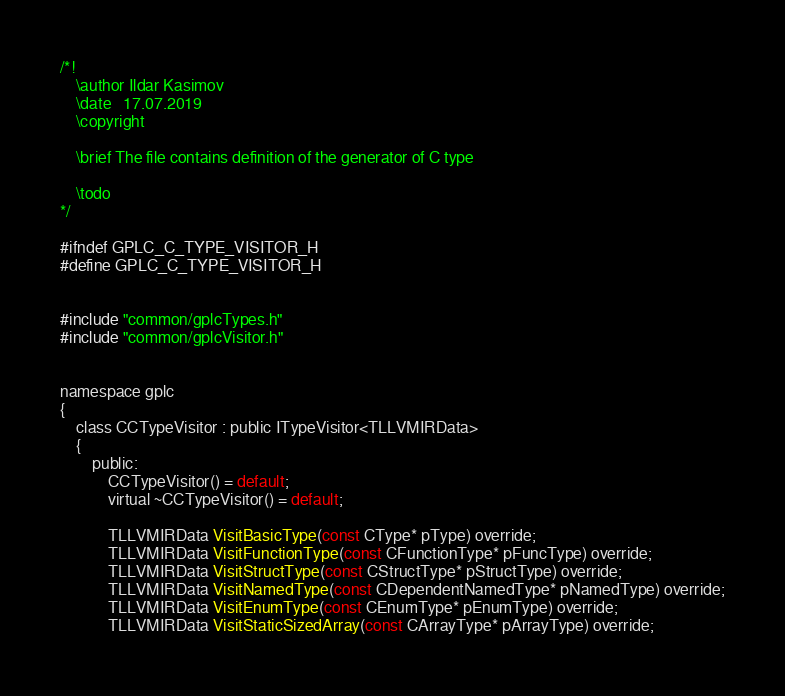Convert code to text. <code><loc_0><loc_0><loc_500><loc_500><_C_>/*!
	\author Ildar Kasimov
	\date   17.07.2019
	\copyright

	\brief The file contains definition of the generator of C type

	\todo
*/

#ifndef GPLC_C_TYPE_VISITOR_H
#define GPLC_C_TYPE_VISITOR_H


#include "common/gplcTypes.h"
#include "common/gplcVisitor.h"


namespace gplc
{
	class CCTypeVisitor : public ITypeVisitor<TLLVMIRData>
	{
		public:
			CCTypeVisitor() = default;
			virtual ~CCTypeVisitor() = default;

			TLLVMIRData VisitBasicType(const CType* pType) override;
			TLLVMIRData VisitFunctionType(const CFunctionType* pFuncType) override; 
			TLLVMIRData VisitStructType(const CStructType* pStructType) override;
			TLLVMIRData VisitNamedType(const CDependentNamedType* pNamedType) override;
			TLLVMIRData VisitEnumType(const CEnumType* pEnumType) override;
			TLLVMIRData VisitStaticSizedArray(const CArrayType* pArrayType) override;</code> 